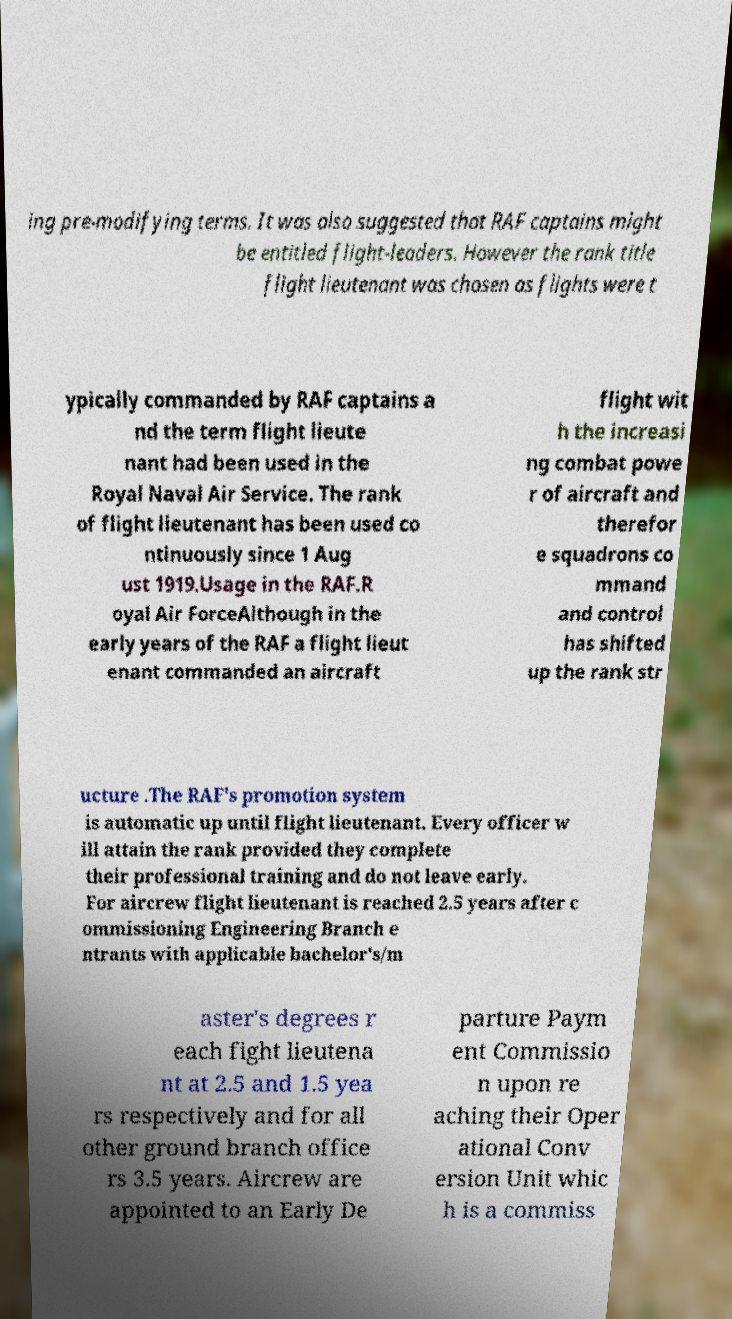For documentation purposes, I need the text within this image transcribed. Could you provide that? ing pre-modifying terms. It was also suggested that RAF captains might be entitled flight-leaders. However the rank title flight lieutenant was chosen as flights were t ypically commanded by RAF captains a nd the term flight lieute nant had been used in the Royal Naval Air Service. The rank of flight lieutenant has been used co ntinuously since 1 Aug ust 1919.Usage in the RAF.R oyal Air ForceAlthough in the early years of the RAF a flight lieut enant commanded an aircraft flight wit h the increasi ng combat powe r of aircraft and therefor e squadrons co mmand and control has shifted up the rank str ucture .The RAF's promotion system is automatic up until flight lieutenant. Every officer w ill attain the rank provided they complete their professional training and do not leave early. For aircrew flight lieutenant is reached 2.5 years after c ommissioning Engineering Branch e ntrants with applicable bachelor's/m aster's degrees r each fight lieutena nt at 2.5 and 1.5 yea rs respectively and for all other ground branch office rs 3.5 years. Aircrew are appointed to an Early De parture Paym ent Commissio n upon re aching their Oper ational Conv ersion Unit whic h is a commiss 